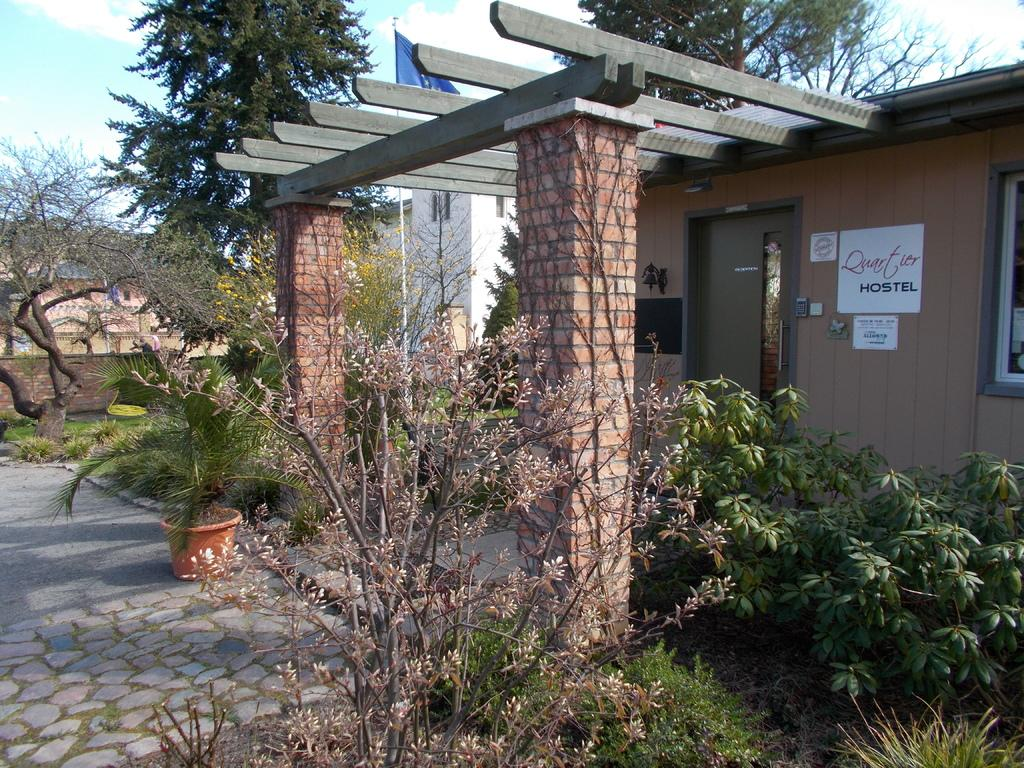What type of plants can be seen in the image? There are small plants in the image. Where are the small plants located? The small plants are in a flower pot in the image. What architectural feature is present in the image? There is a brick arch in the image. What structure can be seen in the image? There is a building in the image. What is attached to a pole in the image? There is a flag on a pole in the image. What can be seen in the background of the image? Trees and the sky are visible in the background of the image. What is present in the sky? There are clouds in the sky. What is the desire of the minister in the image? There is no minister or desire present in the image. What part of the brain can be seen in the image? There is no brain present in the image. 